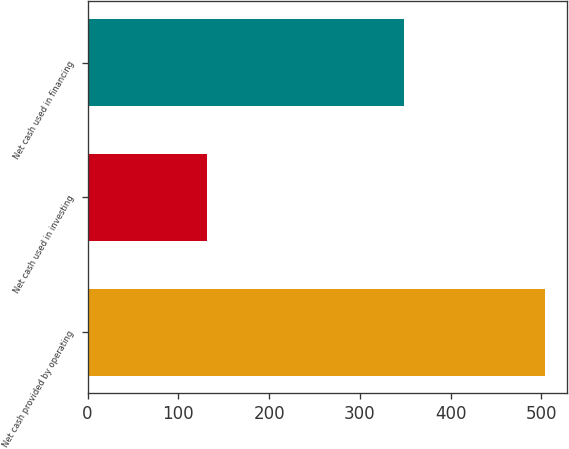Convert chart. <chart><loc_0><loc_0><loc_500><loc_500><bar_chart><fcel>Net cash provided by operating<fcel>Net cash used in investing<fcel>Net cash used in financing<nl><fcel>503.6<fcel>131.6<fcel>348.9<nl></chart> 